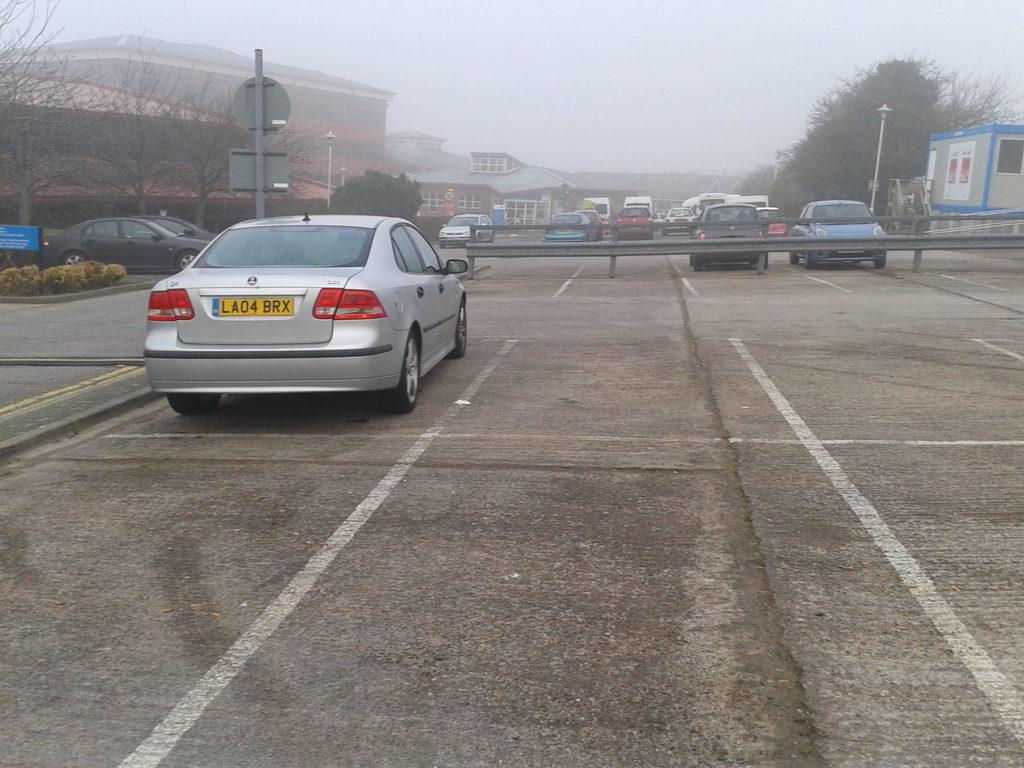Describe this image in one or two sentences. In the foreground, I can see a fence, houseplants, sign boards, light poles and a fleets of vehicles on the road. In the background, I can see trees, buildings and the sky. This image taken, maybe on the road. 